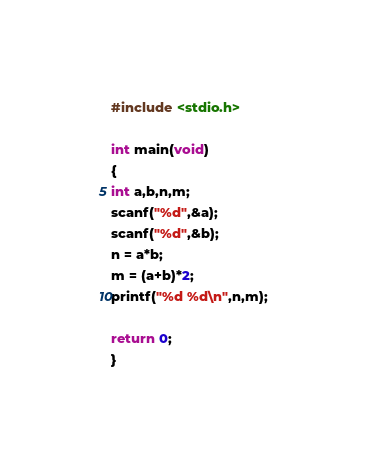Convert code to text. <code><loc_0><loc_0><loc_500><loc_500><_C_>#include <stdio.h>

int main(void)
{
int a,b,n,m;
scanf("%d",&a);
scanf("%d",&b);
n = a*b;
m = (a+b)*2;
printf("%d %d\n",n,m);

return 0;
}</code> 